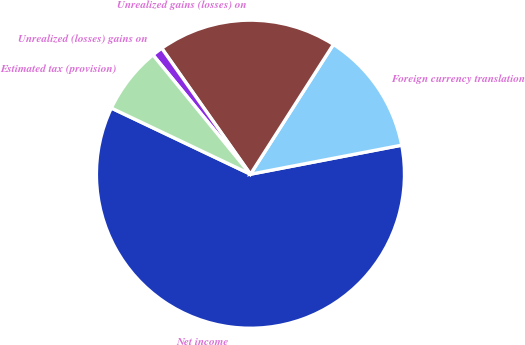Convert chart. <chart><loc_0><loc_0><loc_500><loc_500><pie_chart><fcel>Net income<fcel>Foreign currency translation<fcel>Unrealized gains (losses) on<fcel>Unrealized (losses) gains on<fcel>Estimated tax (provision)<nl><fcel>60.09%<fcel>12.93%<fcel>18.82%<fcel>1.14%<fcel>7.03%<nl></chart> 